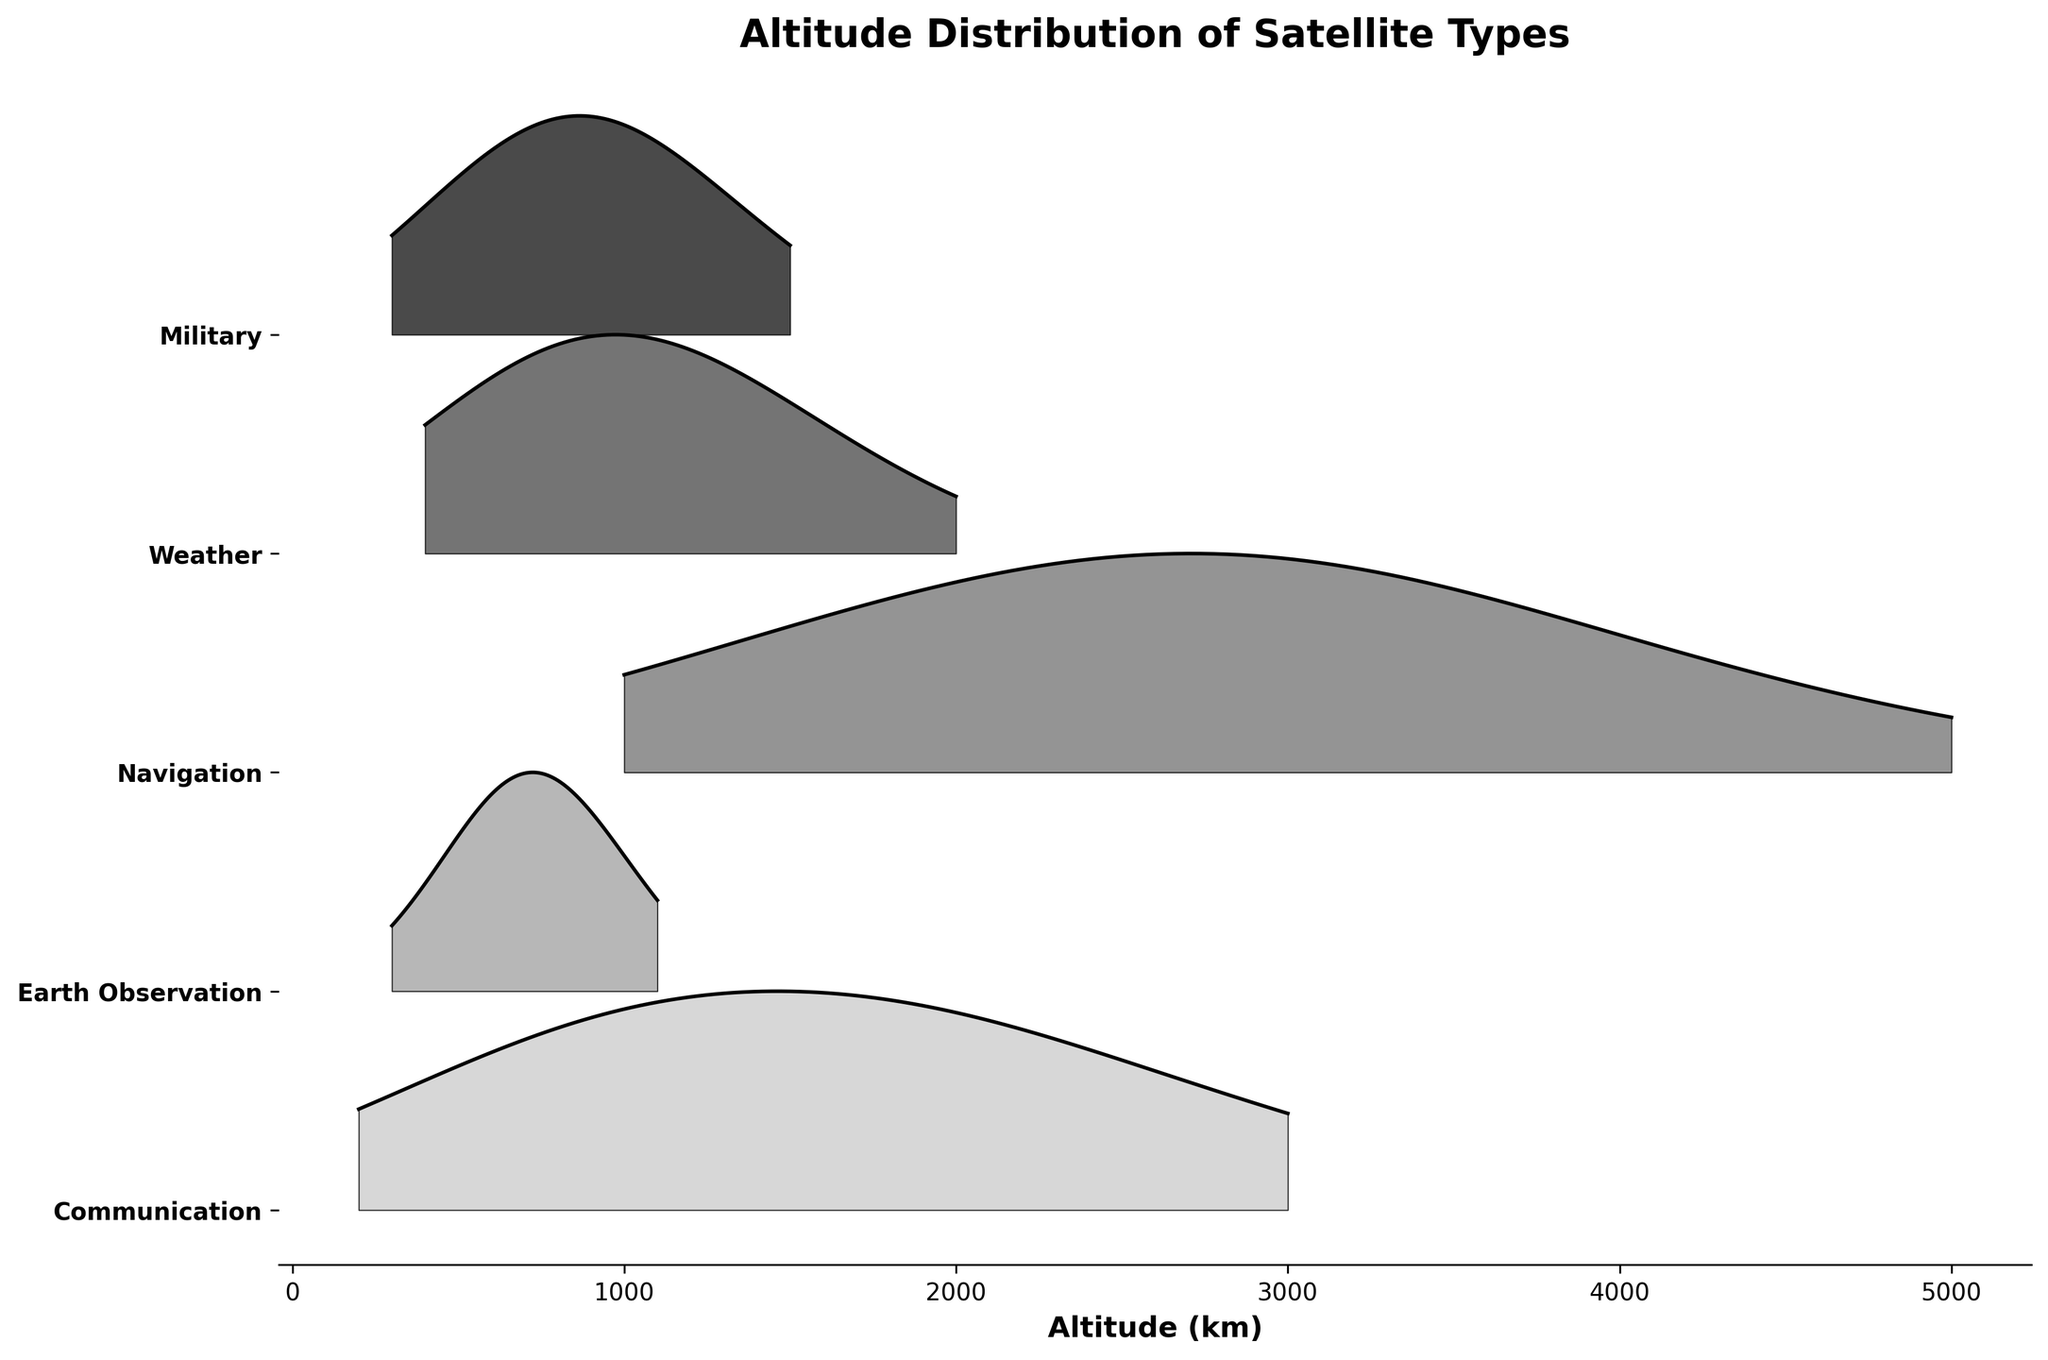What is the title of the plot? The title of the plot is usually located at the top of the figure. In this case, it reads "Altitude Distribution of Satellite Types" as mentioned in the provided code snippet.
Answer: Altitude Distribution of Satellite Types How many different types of satellites are represented in the plot? To find the number of satellite types, we can count the number of distinct labels on the y-axis. Based on the given data and code, they are Communication, Earth Observation, Navigation, Weather, and Military.
Answer: 5 At what altitude does the density peak for Communication satellites? For Communication satellites, we follow the ridgeline curve to identify the highest point on the y-axis (density) relative to the x-axis (altitude). In this case, the density peaks at an altitude of 2000 km.
Answer: 2000 km Which satellite type has the lowest altitude peak density? Looking at the plot, we identify the lowest peak among the ridgelines. Earth Observation satellites peak at an altitude of 700 km, which is the lowest peak compared to other types.
Answer: Earth Observation Compare the peak altitudes of Navigation and Weather satellites. Which is higher? We observe the peak altitudes of both Navigation and Weather satellites on the x-axis. Navigation satellites peak at 3000 km while Weather satellites peak at 800 km. Thus, Navigation has the higher peak altitude.
Answer: Navigation What is the range of altitudes for the Military satellites' density peaks? We look at the ridgeline specific to Military satellites and note the range of x-values where peaks occur. The Military satellites have density peaks ranging from 300 km to 1200 km.
Answer: 300 km to 1200 km Which satellite types have peak density altitudes around 2000 km? By examining the plot, we note which ridgelines hit a peak density near 2000 km. Both Communication and Navigation satellites have peaks around this altitude.
Answer: Communication and Navigation For Earth Observation satellites, by how much does the highest density altitude exceed the lowest density altitude? Identify the highest (700 km) and the lowest (300 km) peak density altitudes for Earth Observation satellites, then subtract the lowest from the highest to find the difference: 700 - 300 = 400.
Answer: 400 km Are there any satellite types that do not have a density peak below 1000 km? Check each satellite type's ridgeline curve for any peaks below 1000 km. Communication and Navigation satellites do not have density peaks below this altitude.
Answer: Communication and Navigation 